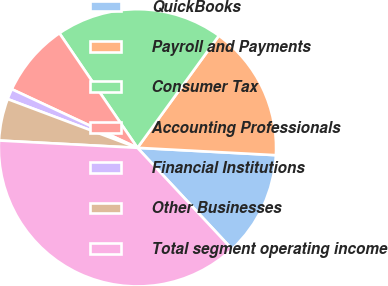Convert chart. <chart><loc_0><loc_0><loc_500><loc_500><pie_chart><fcel>QuickBooks<fcel>Payroll and Payments<fcel>Consumer Tax<fcel>Accounting Professionals<fcel>Financial Institutions<fcel>Other Businesses<fcel>Total segment operating income<nl><fcel>12.2%<fcel>15.85%<fcel>19.51%<fcel>8.54%<fcel>1.23%<fcel>4.88%<fcel>37.79%<nl></chart> 